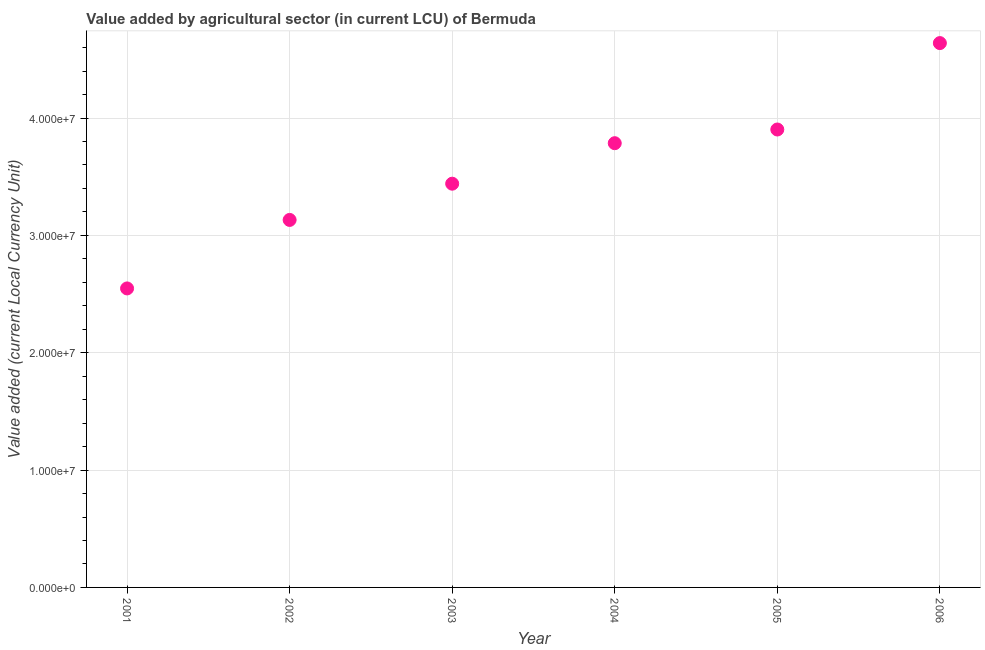What is the value added by agriculture sector in 2005?
Your answer should be compact. 3.90e+07. Across all years, what is the maximum value added by agriculture sector?
Give a very brief answer. 4.64e+07. Across all years, what is the minimum value added by agriculture sector?
Provide a succinct answer. 2.55e+07. In which year was the value added by agriculture sector minimum?
Give a very brief answer. 2001. What is the sum of the value added by agriculture sector?
Provide a short and direct response. 2.14e+08. What is the difference between the value added by agriculture sector in 2003 and 2004?
Your answer should be very brief. -3.45e+06. What is the average value added by agriculture sector per year?
Make the answer very short. 3.57e+07. What is the median value added by agriculture sector?
Make the answer very short. 3.61e+07. What is the ratio of the value added by agriculture sector in 2002 to that in 2006?
Ensure brevity in your answer.  0.68. Is the value added by agriculture sector in 2002 less than that in 2005?
Provide a succinct answer. Yes. Is the difference between the value added by agriculture sector in 2001 and 2003 greater than the difference between any two years?
Provide a short and direct response. No. What is the difference between the highest and the second highest value added by agriculture sector?
Provide a short and direct response. 7.36e+06. Is the sum of the value added by agriculture sector in 2001 and 2002 greater than the maximum value added by agriculture sector across all years?
Make the answer very short. Yes. What is the difference between the highest and the lowest value added by agriculture sector?
Provide a succinct answer. 2.09e+07. Does the value added by agriculture sector monotonically increase over the years?
Ensure brevity in your answer.  Yes. How many years are there in the graph?
Make the answer very short. 6. Does the graph contain grids?
Provide a succinct answer. Yes. What is the title of the graph?
Make the answer very short. Value added by agricultural sector (in current LCU) of Bermuda. What is the label or title of the X-axis?
Make the answer very short. Year. What is the label or title of the Y-axis?
Provide a succinct answer. Value added (current Local Currency Unit). What is the Value added (current Local Currency Unit) in 2001?
Make the answer very short. 2.55e+07. What is the Value added (current Local Currency Unit) in 2002?
Provide a succinct answer. 3.13e+07. What is the Value added (current Local Currency Unit) in 2003?
Your answer should be compact. 3.44e+07. What is the Value added (current Local Currency Unit) in 2004?
Keep it short and to the point. 3.79e+07. What is the Value added (current Local Currency Unit) in 2005?
Give a very brief answer. 3.90e+07. What is the Value added (current Local Currency Unit) in 2006?
Keep it short and to the point. 4.64e+07. What is the difference between the Value added (current Local Currency Unit) in 2001 and 2002?
Ensure brevity in your answer.  -5.84e+06. What is the difference between the Value added (current Local Currency Unit) in 2001 and 2003?
Offer a terse response. -8.93e+06. What is the difference between the Value added (current Local Currency Unit) in 2001 and 2004?
Give a very brief answer. -1.24e+07. What is the difference between the Value added (current Local Currency Unit) in 2001 and 2005?
Offer a terse response. -1.35e+07. What is the difference between the Value added (current Local Currency Unit) in 2001 and 2006?
Offer a terse response. -2.09e+07. What is the difference between the Value added (current Local Currency Unit) in 2002 and 2003?
Provide a succinct answer. -3.09e+06. What is the difference between the Value added (current Local Currency Unit) in 2002 and 2004?
Ensure brevity in your answer.  -6.54e+06. What is the difference between the Value added (current Local Currency Unit) in 2002 and 2005?
Your answer should be very brief. -7.71e+06. What is the difference between the Value added (current Local Currency Unit) in 2002 and 2006?
Your response must be concise. -1.51e+07. What is the difference between the Value added (current Local Currency Unit) in 2003 and 2004?
Make the answer very short. -3.45e+06. What is the difference between the Value added (current Local Currency Unit) in 2003 and 2005?
Make the answer very short. -4.62e+06. What is the difference between the Value added (current Local Currency Unit) in 2003 and 2006?
Provide a succinct answer. -1.20e+07. What is the difference between the Value added (current Local Currency Unit) in 2004 and 2005?
Offer a very short reply. -1.17e+06. What is the difference between the Value added (current Local Currency Unit) in 2004 and 2006?
Your answer should be very brief. -8.53e+06. What is the difference between the Value added (current Local Currency Unit) in 2005 and 2006?
Provide a short and direct response. -7.36e+06. What is the ratio of the Value added (current Local Currency Unit) in 2001 to that in 2002?
Make the answer very short. 0.81. What is the ratio of the Value added (current Local Currency Unit) in 2001 to that in 2003?
Give a very brief answer. 0.74. What is the ratio of the Value added (current Local Currency Unit) in 2001 to that in 2004?
Your answer should be compact. 0.67. What is the ratio of the Value added (current Local Currency Unit) in 2001 to that in 2005?
Make the answer very short. 0.65. What is the ratio of the Value added (current Local Currency Unit) in 2001 to that in 2006?
Give a very brief answer. 0.55. What is the ratio of the Value added (current Local Currency Unit) in 2002 to that in 2003?
Offer a terse response. 0.91. What is the ratio of the Value added (current Local Currency Unit) in 2002 to that in 2004?
Ensure brevity in your answer.  0.83. What is the ratio of the Value added (current Local Currency Unit) in 2002 to that in 2005?
Your answer should be very brief. 0.8. What is the ratio of the Value added (current Local Currency Unit) in 2002 to that in 2006?
Your answer should be very brief. 0.68. What is the ratio of the Value added (current Local Currency Unit) in 2003 to that in 2004?
Provide a succinct answer. 0.91. What is the ratio of the Value added (current Local Currency Unit) in 2003 to that in 2005?
Your answer should be compact. 0.88. What is the ratio of the Value added (current Local Currency Unit) in 2003 to that in 2006?
Your response must be concise. 0.74. What is the ratio of the Value added (current Local Currency Unit) in 2004 to that in 2005?
Provide a succinct answer. 0.97. What is the ratio of the Value added (current Local Currency Unit) in 2004 to that in 2006?
Offer a terse response. 0.82. What is the ratio of the Value added (current Local Currency Unit) in 2005 to that in 2006?
Give a very brief answer. 0.84. 